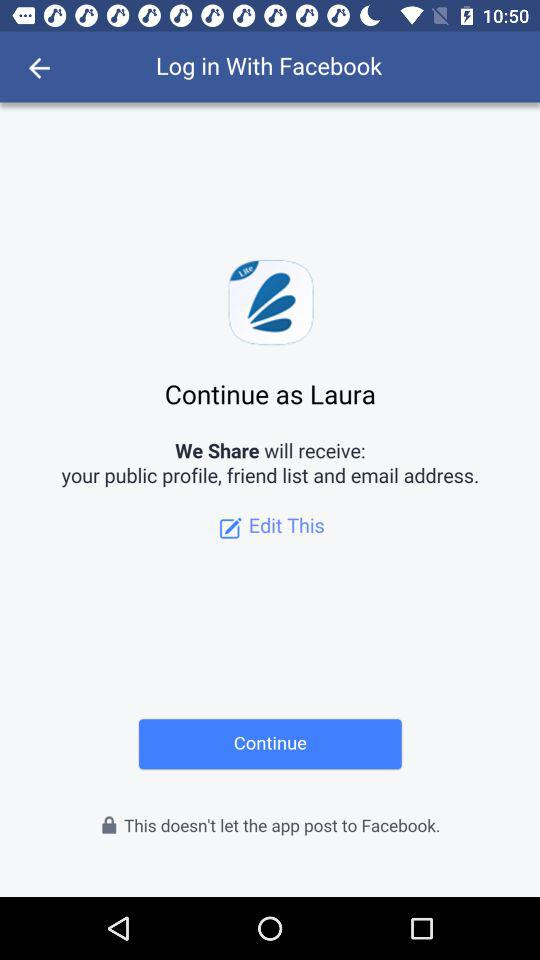What is the user name? The user name is Laura. 